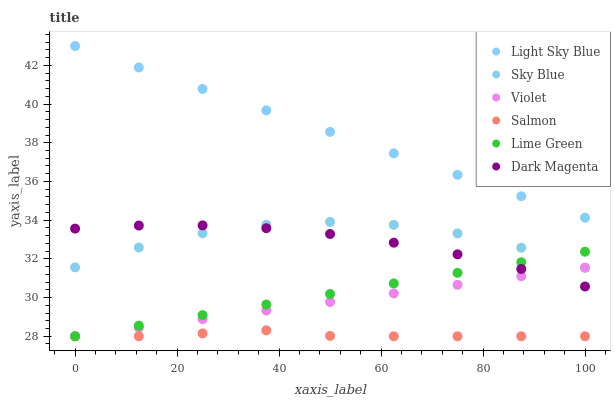Does Salmon have the minimum area under the curve?
Answer yes or no. Yes. Does Light Sky Blue have the maximum area under the curve?
Answer yes or no. Yes. Does Light Sky Blue have the minimum area under the curve?
Answer yes or no. No. Does Salmon have the maximum area under the curve?
Answer yes or no. No. Is Light Sky Blue the smoothest?
Answer yes or no. Yes. Is Sky Blue the roughest?
Answer yes or no. Yes. Is Salmon the smoothest?
Answer yes or no. No. Is Salmon the roughest?
Answer yes or no. No. Does Salmon have the lowest value?
Answer yes or no. Yes. Does Light Sky Blue have the lowest value?
Answer yes or no. No. Does Light Sky Blue have the highest value?
Answer yes or no. Yes. Does Salmon have the highest value?
Answer yes or no. No. Is Salmon less than Dark Magenta?
Answer yes or no. Yes. Is Dark Magenta greater than Salmon?
Answer yes or no. Yes. Does Lime Green intersect Violet?
Answer yes or no. Yes. Is Lime Green less than Violet?
Answer yes or no. No. Is Lime Green greater than Violet?
Answer yes or no. No. Does Salmon intersect Dark Magenta?
Answer yes or no. No. 